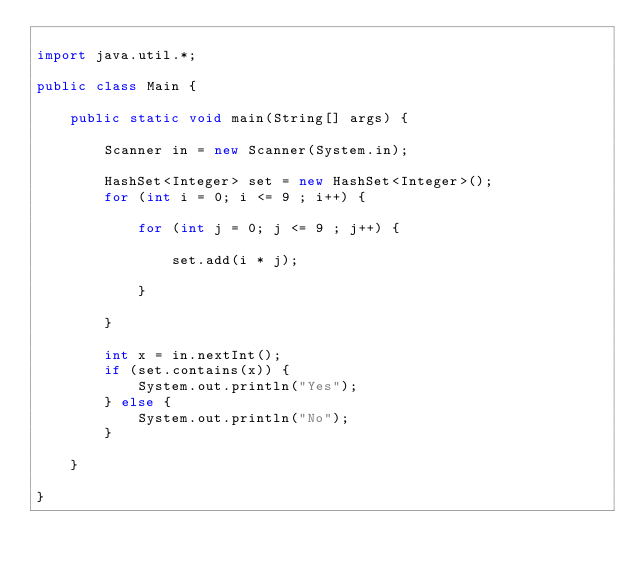<code> <loc_0><loc_0><loc_500><loc_500><_Java_>
import java.util.*;

public class Main {

    public static void main(String[] args) {

        Scanner in = new Scanner(System.in);

        HashSet<Integer> set = new HashSet<Integer>();
        for (int i = 0; i <= 9 ; i++) {

            for (int j = 0; j <= 9 ; j++) {

                set.add(i * j);

            }

        }

        int x = in.nextInt();
        if (set.contains(x)) {
            System.out.println("Yes");
        } else {
            System.out.println("No");
        }

    }

}
</code> 